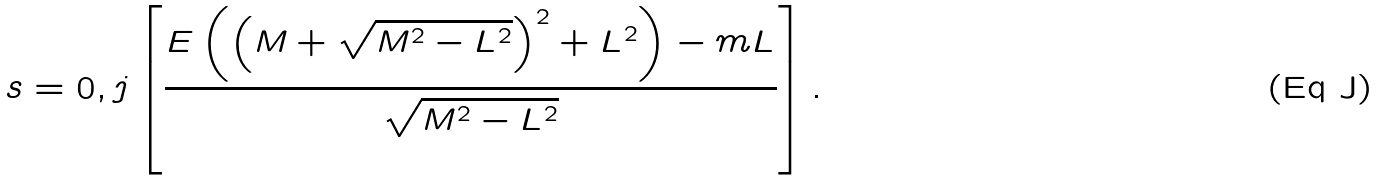<formula> <loc_0><loc_0><loc_500><loc_500>s = 0 , j \left [ \frac { E \left ( \left ( M + \sqrt { M ^ { 2 } - L ^ { 2 } } \right ) ^ { 2 } + L ^ { 2 } \right ) - m L } { \sqrt { M ^ { 2 } - L ^ { 2 } } } \right ] .</formula> 